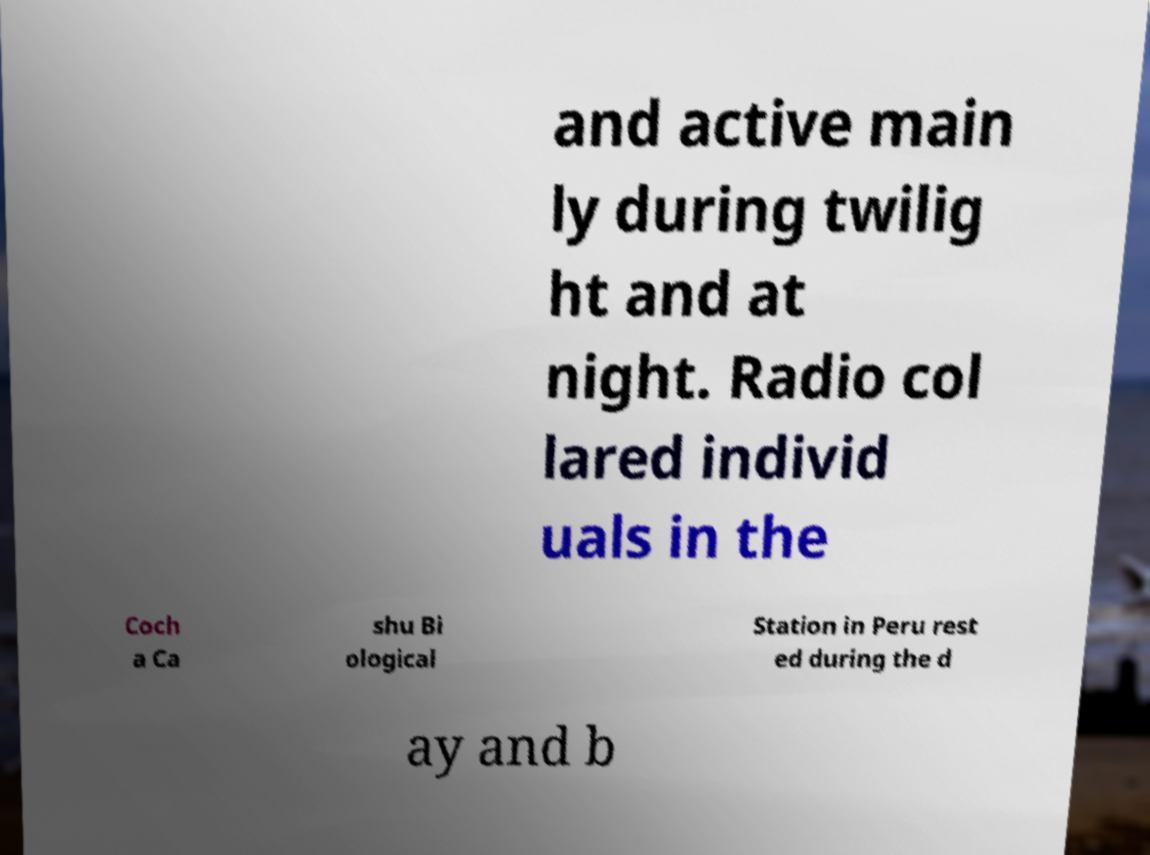Can you read and provide the text displayed in the image?This photo seems to have some interesting text. Can you extract and type it out for me? and active main ly during twilig ht and at night. Radio col lared individ uals in the Coch a Ca shu Bi ological Station in Peru rest ed during the d ay and b 